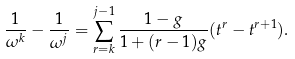<formula> <loc_0><loc_0><loc_500><loc_500>\frac { 1 } { \omega ^ { k } } - \frac { 1 } { \omega ^ { j } } = \sum _ { r = k } ^ { j - 1 } \frac { 1 - g } { 1 + ( r - 1 ) g } ( t ^ { r } - t ^ { r + 1 } ) .</formula> 